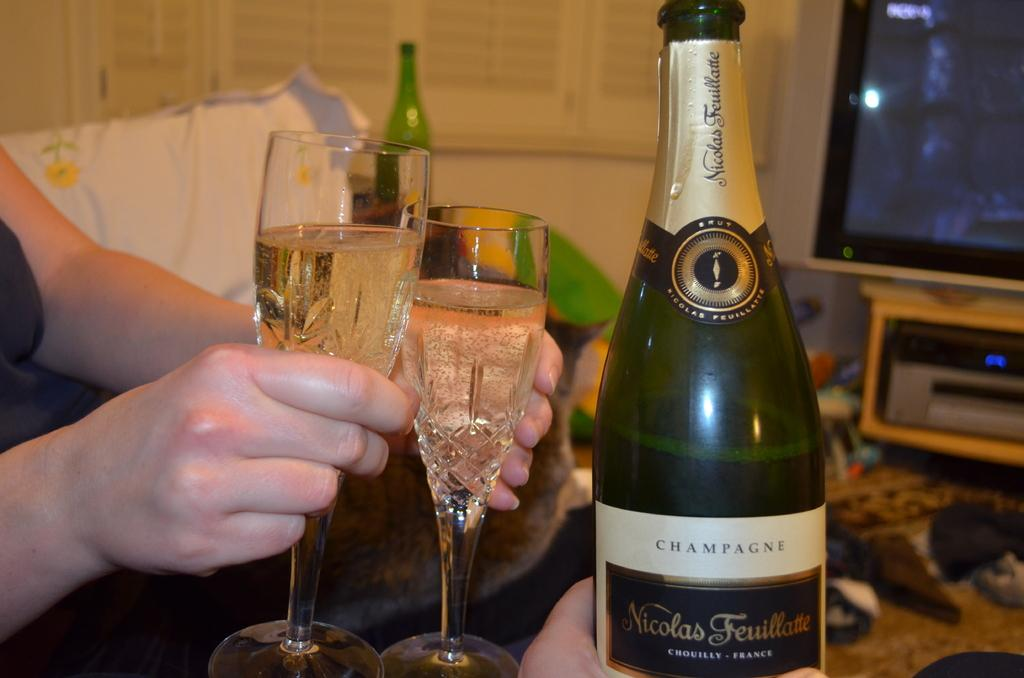Provide a one-sentence caption for the provided image. A bottle of CHAMPAGNE with 2 glasses next to it held by a person. 